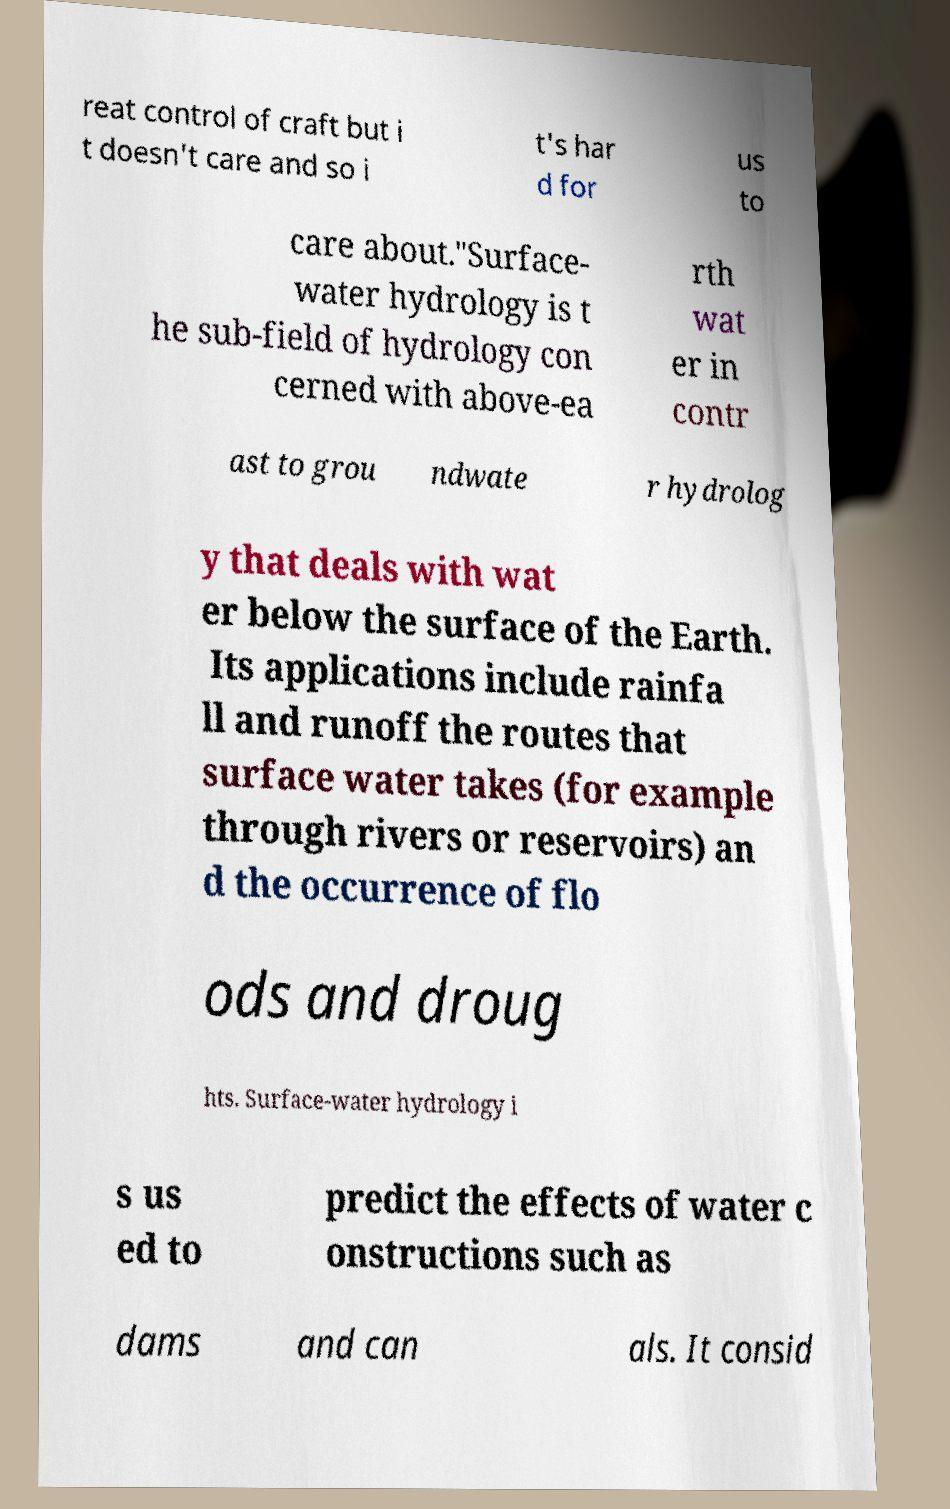Could you assist in decoding the text presented in this image and type it out clearly? reat control of craft but i t doesn't care and so i t's har d for us to care about."Surface- water hydrology is t he sub-field of hydrology con cerned with above-ea rth wat er in contr ast to grou ndwate r hydrolog y that deals with wat er below the surface of the Earth. Its applications include rainfa ll and runoff the routes that surface water takes (for example through rivers or reservoirs) an d the occurrence of flo ods and droug hts. Surface-water hydrology i s us ed to predict the effects of water c onstructions such as dams and can als. It consid 